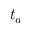<formula> <loc_0><loc_0><loc_500><loc_500>t _ { a }</formula> 